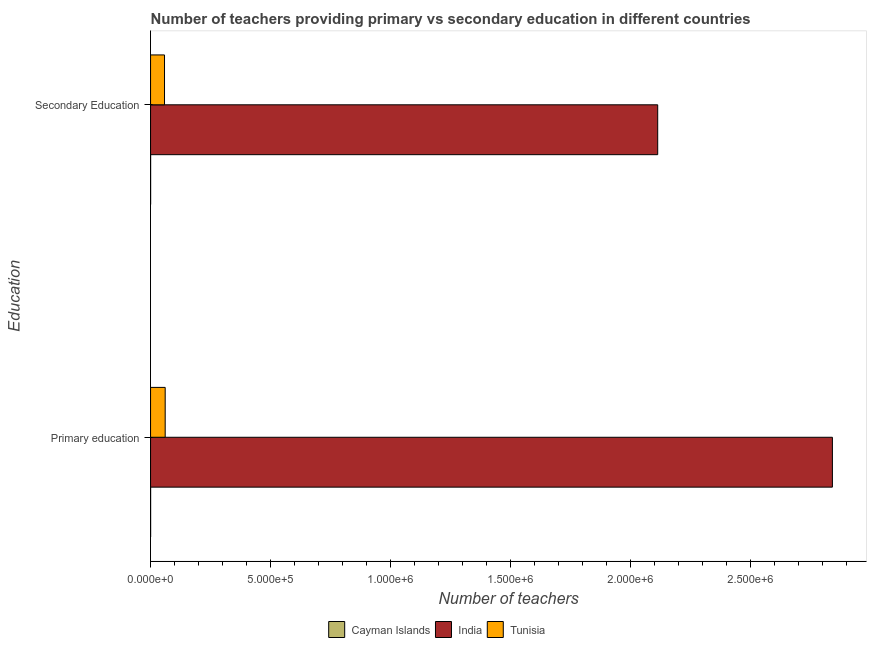Are the number of bars per tick equal to the number of legend labels?
Keep it short and to the point. Yes. How many bars are there on the 2nd tick from the bottom?
Offer a very short reply. 3. What is the label of the 1st group of bars from the top?
Make the answer very short. Secondary Education. What is the number of secondary teachers in India?
Your response must be concise. 2.11e+06. Across all countries, what is the maximum number of secondary teachers?
Offer a very short reply. 2.11e+06. Across all countries, what is the minimum number of secondary teachers?
Ensure brevity in your answer.  252. In which country was the number of secondary teachers maximum?
Provide a succinct answer. India. In which country was the number of secondary teachers minimum?
Your answer should be very brief. Cayman Islands. What is the total number of primary teachers in the graph?
Provide a succinct answer. 2.90e+06. What is the difference between the number of primary teachers in Cayman Islands and that in Tunisia?
Your answer should be very brief. -6.07e+04. What is the difference between the number of primary teachers in Tunisia and the number of secondary teachers in India?
Provide a succinct answer. -2.05e+06. What is the average number of primary teachers per country?
Your answer should be very brief. 9.67e+05. What is the difference between the number of primary teachers and number of secondary teachers in Cayman Islands?
Offer a very short reply. -15. In how many countries, is the number of primary teachers greater than 2100000 ?
Ensure brevity in your answer.  1. What is the ratio of the number of primary teachers in Cayman Islands to that in Tunisia?
Provide a short and direct response. 0. What does the 1st bar from the top in Secondary Education represents?
Provide a succinct answer. Tunisia. Are all the bars in the graph horizontal?
Make the answer very short. Yes. How many countries are there in the graph?
Provide a short and direct response. 3. What is the difference between two consecutive major ticks on the X-axis?
Keep it short and to the point. 5.00e+05. Are the values on the major ticks of X-axis written in scientific E-notation?
Ensure brevity in your answer.  Yes. Where does the legend appear in the graph?
Ensure brevity in your answer.  Bottom center. What is the title of the graph?
Ensure brevity in your answer.  Number of teachers providing primary vs secondary education in different countries. What is the label or title of the X-axis?
Provide a short and direct response. Number of teachers. What is the label or title of the Y-axis?
Keep it short and to the point. Education. What is the Number of teachers of Cayman Islands in Primary education?
Make the answer very short. 237. What is the Number of teachers in India in Primary education?
Your answer should be very brief. 2.84e+06. What is the Number of teachers in Tunisia in Primary education?
Your answer should be very brief. 6.09e+04. What is the Number of teachers in Cayman Islands in Secondary Education?
Keep it short and to the point. 252. What is the Number of teachers of India in Secondary Education?
Offer a very short reply. 2.11e+06. What is the Number of teachers of Tunisia in Secondary Education?
Give a very brief answer. 5.81e+04. Across all Education, what is the maximum Number of teachers of Cayman Islands?
Ensure brevity in your answer.  252. Across all Education, what is the maximum Number of teachers in India?
Offer a terse response. 2.84e+06. Across all Education, what is the maximum Number of teachers of Tunisia?
Ensure brevity in your answer.  6.09e+04. Across all Education, what is the minimum Number of teachers in Cayman Islands?
Your answer should be very brief. 237. Across all Education, what is the minimum Number of teachers in India?
Provide a succinct answer. 2.11e+06. Across all Education, what is the minimum Number of teachers of Tunisia?
Ensure brevity in your answer.  5.81e+04. What is the total Number of teachers of Cayman Islands in the graph?
Give a very brief answer. 489. What is the total Number of teachers in India in the graph?
Offer a very short reply. 4.95e+06. What is the total Number of teachers of Tunisia in the graph?
Keep it short and to the point. 1.19e+05. What is the difference between the Number of teachers of India in Primary education and that in Secondary Education?
Make the answer very short. 7.28e+05. What is the difference between the Number of teachers of Tunisia in Primary education and that in Secondary Education?
Give a very brief answer. 2780. What is the difference between the Number of teachers of Cayman Islands in Primary education and the Number of teachers of India in Secondary Education?
Ensure brevity in your answer.  -2.11e+06. What is the difference between the Number of teachers of Cayman Islands in Primary education and the Number of teachers of Tunisia in Secondary Education?
Offer a very short reply. -5.79e+04. What is the difference between the Number of teachers of India in Primary education and the Number of teachers of Tunisia in Secondary Education?
Provide a short and direct response. 2.78e+06. What is the average Number of teachers in Cayman Islands per Education?
Provide a short and direct response. 244.5. What is the average Number of teachers in India per Education?
Make the answer very short. 2.48e+06. What is the average Number of teachers in Tunisia per Education?
Your answer should be compact. 5.95e+04. What is the difference between the Number of teachers in Cayman Islands and Number of teachers in India in Primary education?
Your answer should be very brief. -2.84e+06. What is the difference between the Number of teachers in Cayman Islands and Number of teachers in Tunisia in Primary education?
Offer a very short reply. -6.07e+04. What is the difference between the Number of teachers of India and Number of teachers of Tunisia in Primary education?
Offer a very short reply. 2.78e+06. What is the difference between the Number of teachers in Cayman Islands and Number of teachers in India in Secondary Education?
Ensure brevity in your answer.  -2.11e+06. What is the difference between the Number of teachers of Cayman Islands and Number of teachers of Tunisia in Secondary Education?
Offer a terse response. -5.79e+04. What is the difference between the Number of teachers in India and Number of teachers in Tunisia in Secondary Education?
Your answer should be compact. 2.05e+06. What is the ratio of the Number of teachers of Cayman Islands in Primary education to that in Secondary Education?
Give a very brief answer. 0.94. What is the ratio of the Number of teachers in India in Primary education to that in Secondary Education?
Make the answer very short. 1.34. What is the ratio of the Number of teachers in Tunisia in Primary education to that in Secondary Education?
Provide a short and direct response. 1.05. What is the difference between the highest and the second highest Number of teachers in India?
Provide a short and direct response. 7.28e+05. What is the difference between the highest and the second highest Number of teachers of Tunisia?
Keep it short and to the point. 2780. What is the difference between the highest and the lowest Number of teachers in India?
Offer a very short reply. 7.28e+05. What is the difference between the highest and the lowest Number of teachers in Tunisia?
Provide a short and direct response. 2780. 